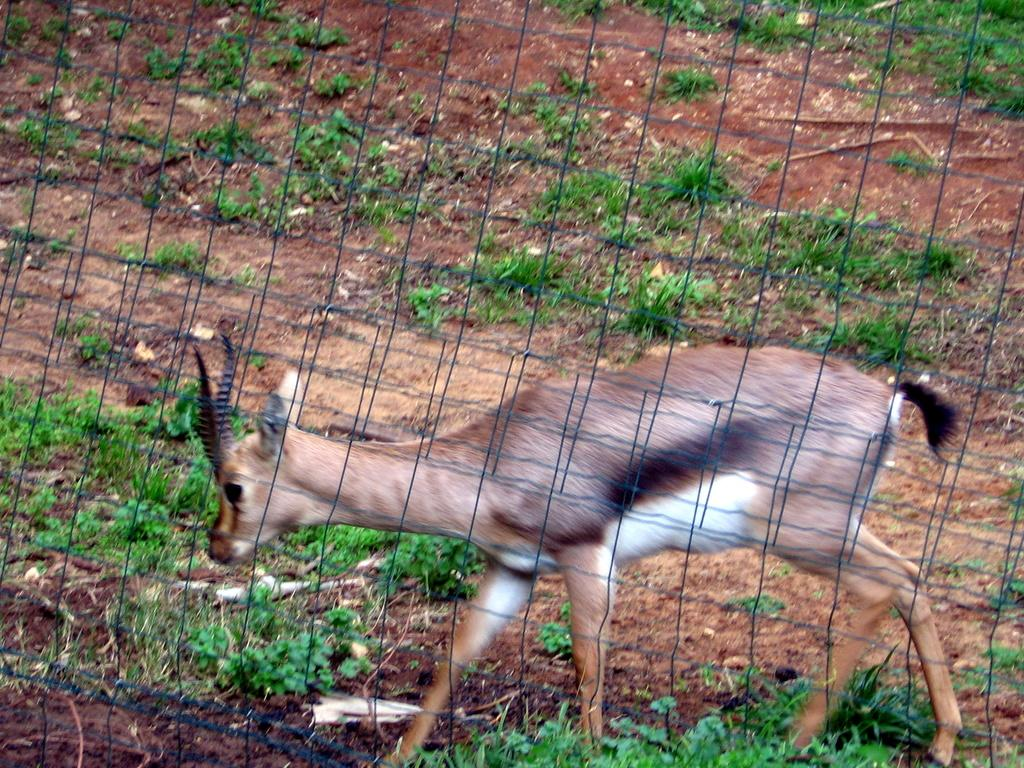Where was the picture taken? The picture was clicked outside. What can be seen in the foreground of the image? There is a net in the foreground of the image. What is the animal doing in the image? An animal is walking on the ground in the image. What type of natural elements can be seen in the image? There are plants visible in the image. Can you describe any other items present in the image? There are other unspecified items in the image. What type of paste is being used to fix the engine in the image? There is no mention of paste or an engine in the image; it features a net, an animal walking on the ground, plants, and other unspecified items. 